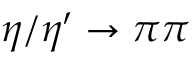<formula> <loc_0><loc_0><loc_500><loc_500>\eta / \eta ^ { \prime } \to \pi \pi</formula> 